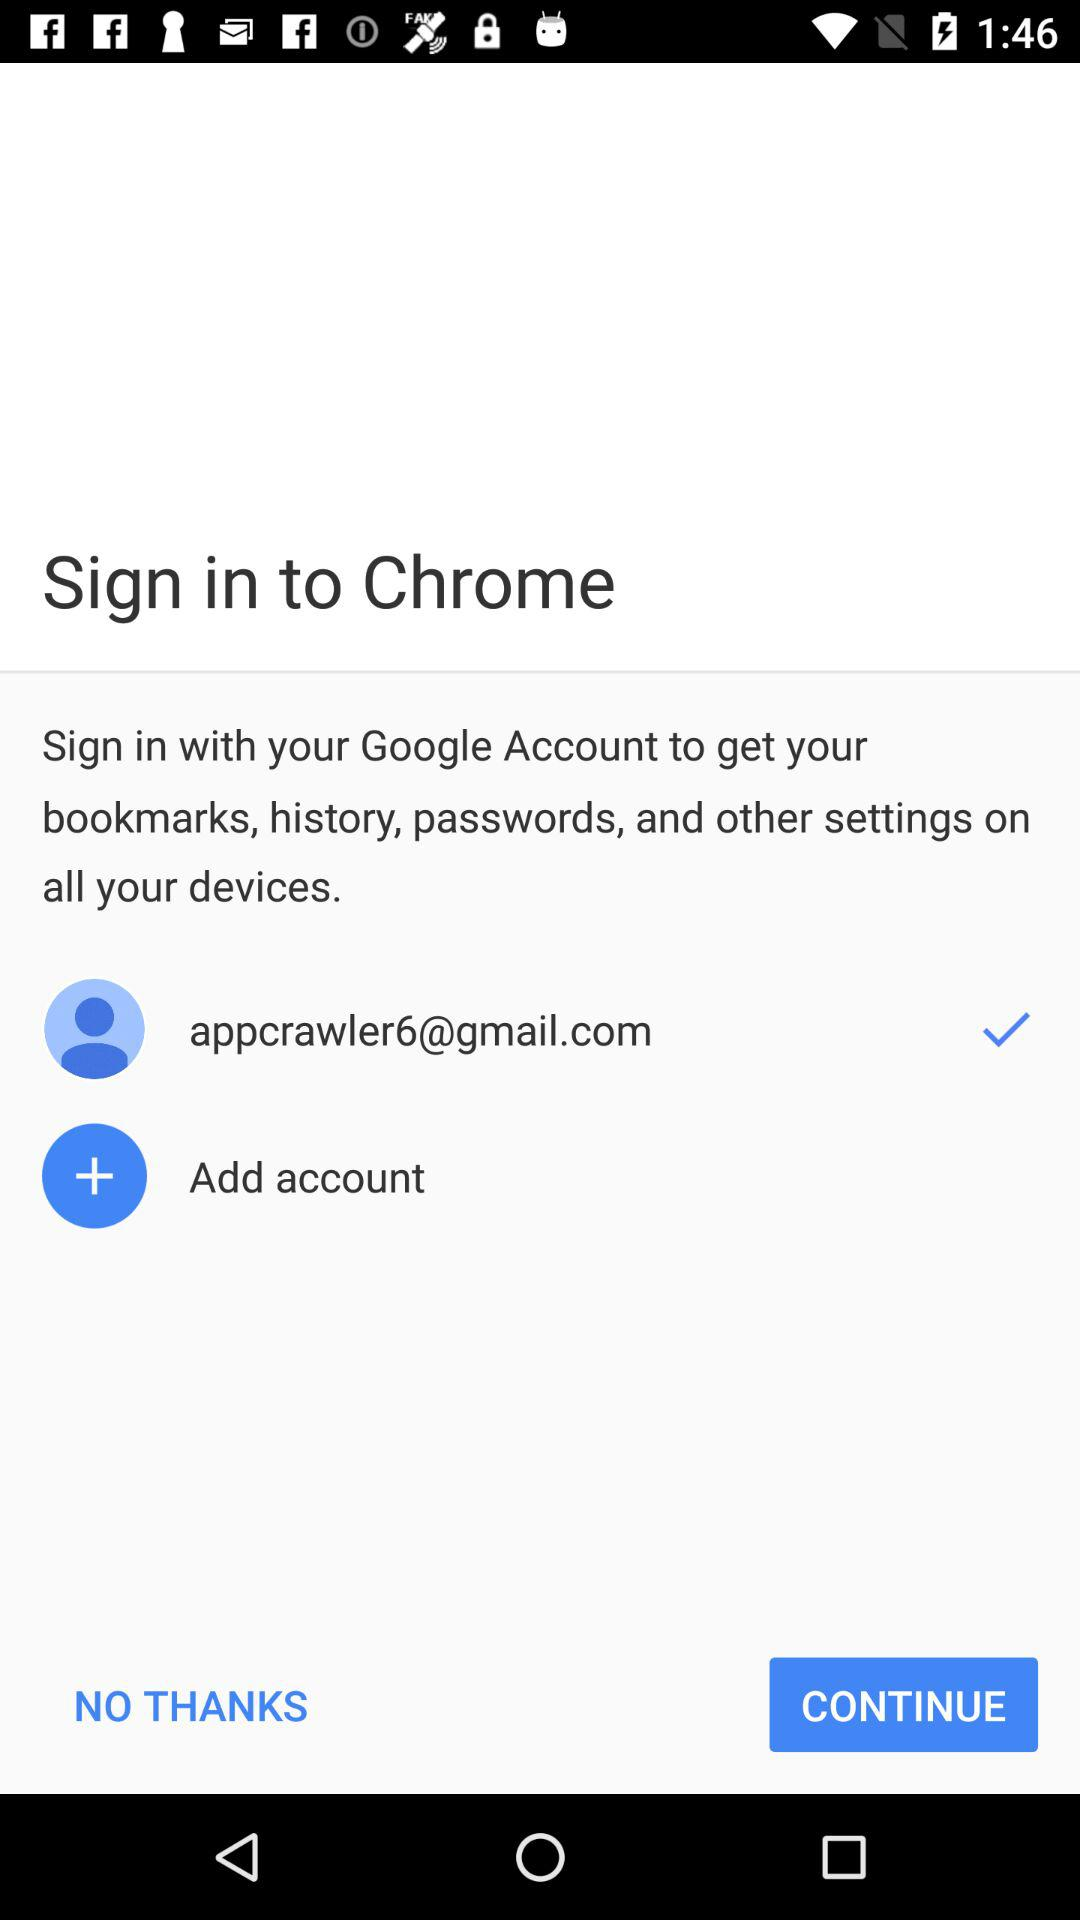What email ID is used for sign in? The email ID used is appcrawler6@gmail.com. 